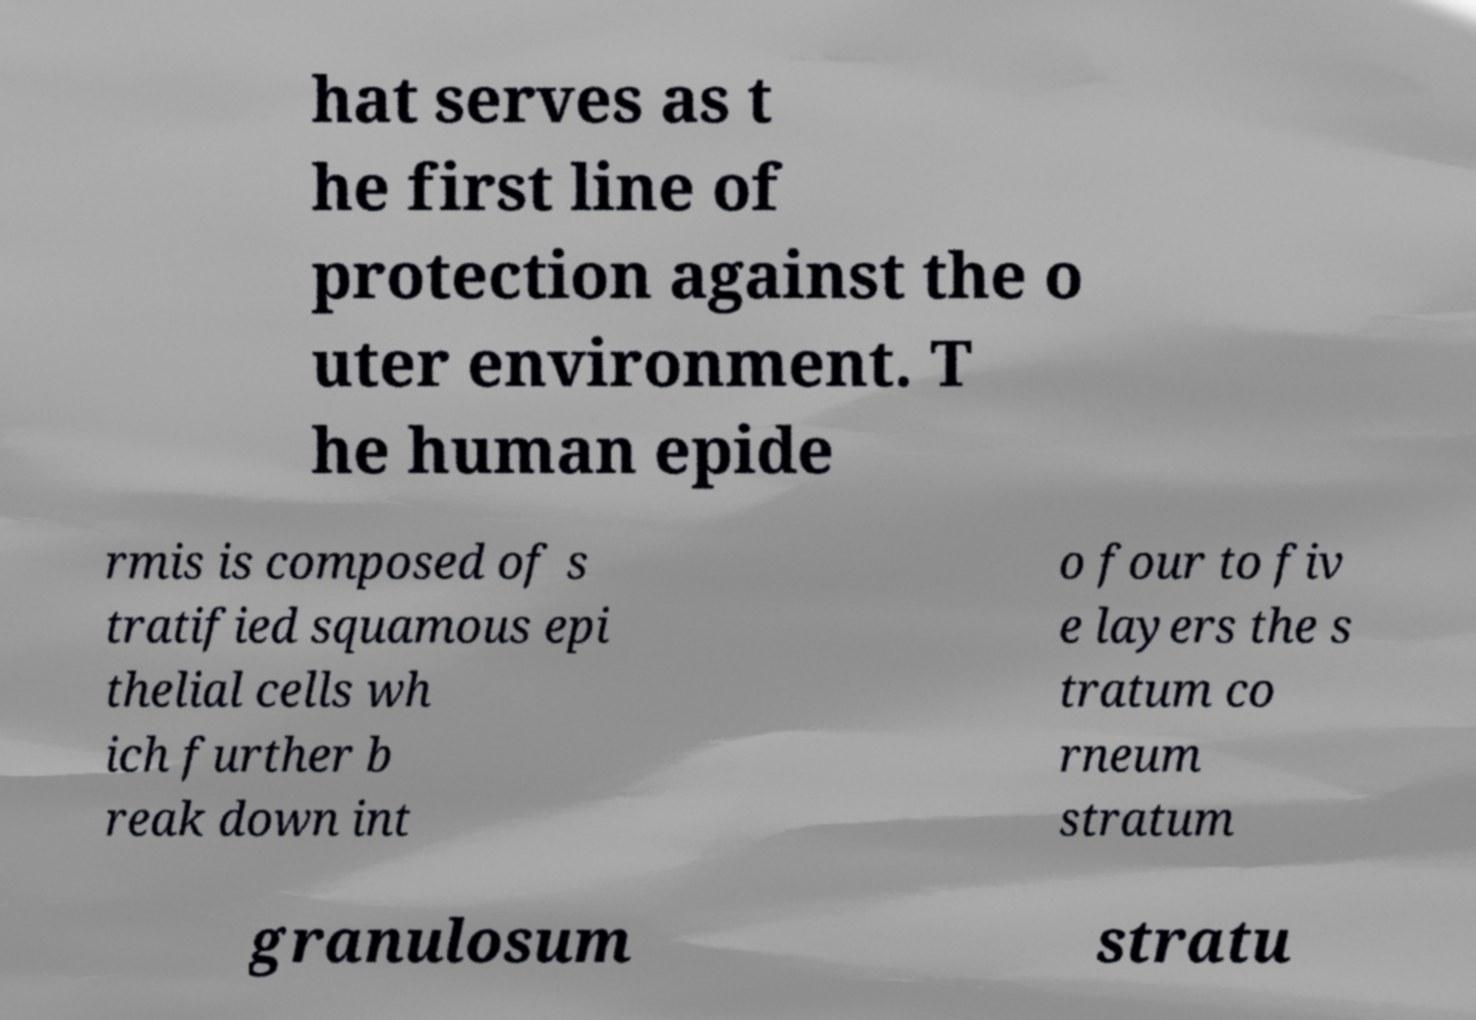There's text embedded in this image that I need extracted. Can you transcribe it verbatim? hat serves as t he first line of protection against the o uter environment. T he human epide rmis is composed of s tratified squamous epi thelial cells wh ich further b reak down int o four to fiv e layers the s tratum co rneum stratum granulosum stratu 